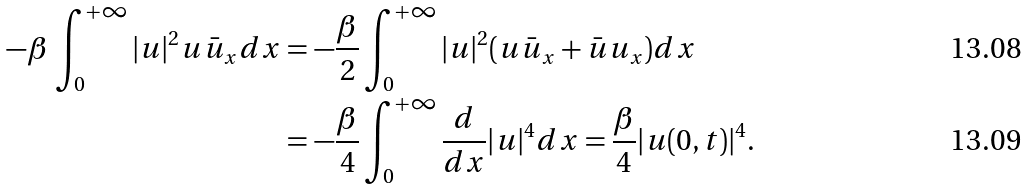Convert formula to latex. <formula><loc_0><loc_0><loc_500><loc_500>- \beta \, \int _ { 0 } ^ { + \infty } | u | ^ { 2 } u \bar { u } _ { x } d x & = - \frac { \beta } { 2 } \int _ { 0 } ^ { + \infty } | u | ^ { 2 } ( u \bar { u } _ { x } + \bar { u } u _ { x } ) d x \\ & = - \frac { \beta } { 4 } \int _ { 0 } ^ { + \infty } \frac { d } { d x } | u | ^ { 4 } d x = \frac { \beta } { 4 } | u ( 0 , t ) | ^ { 4 } .</formula> 